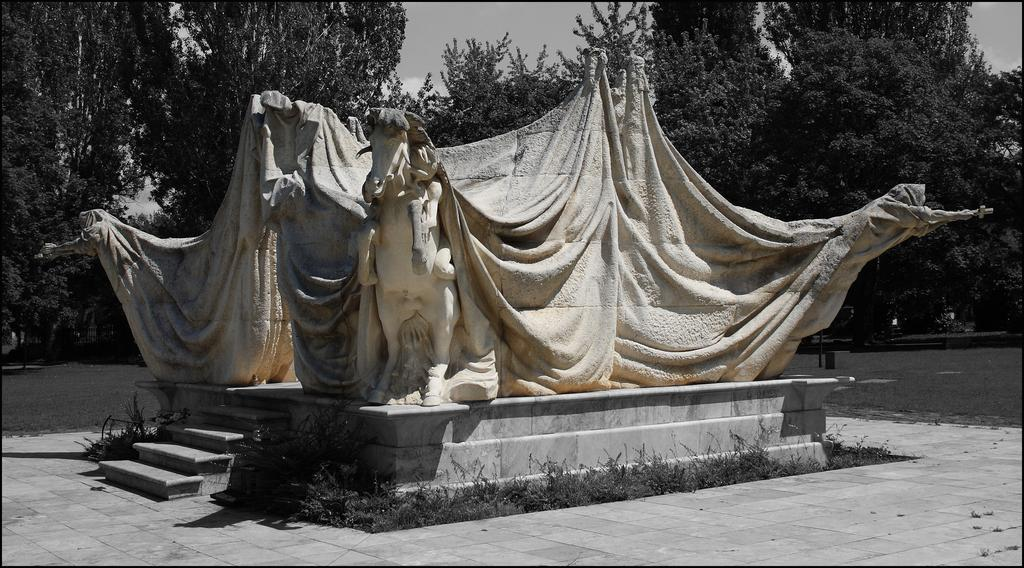What type of animals are depicted as statues in the image? There are statues of horses in the image. What else can be seen in the image besides the statues? There are other objects in the image. What can be seen in the background of the image? There are trees in the background of the image. How many feet are visible on the zipper in the image? There is no zipper present in the image, so it is not possible to determine the number of feet visible on it. 